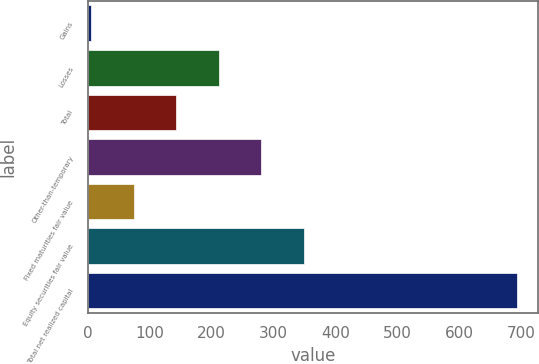<chart> <loc_0><loc_0><loc_500><loc_500><bar_chart><fcel>Gains<fcel>Losses<fcel>Total<fcel>Other-than-temporary<fcel>Fixed maturities fair value<fcel>Equity securities fair value<fcel>Total net realized capital<nl><fcel>5.2<fcel>211.69<fcel>142.86<fcel>280.52<fcel>74.03<fcel>349.35<fcel>693.5<nl></chart> 